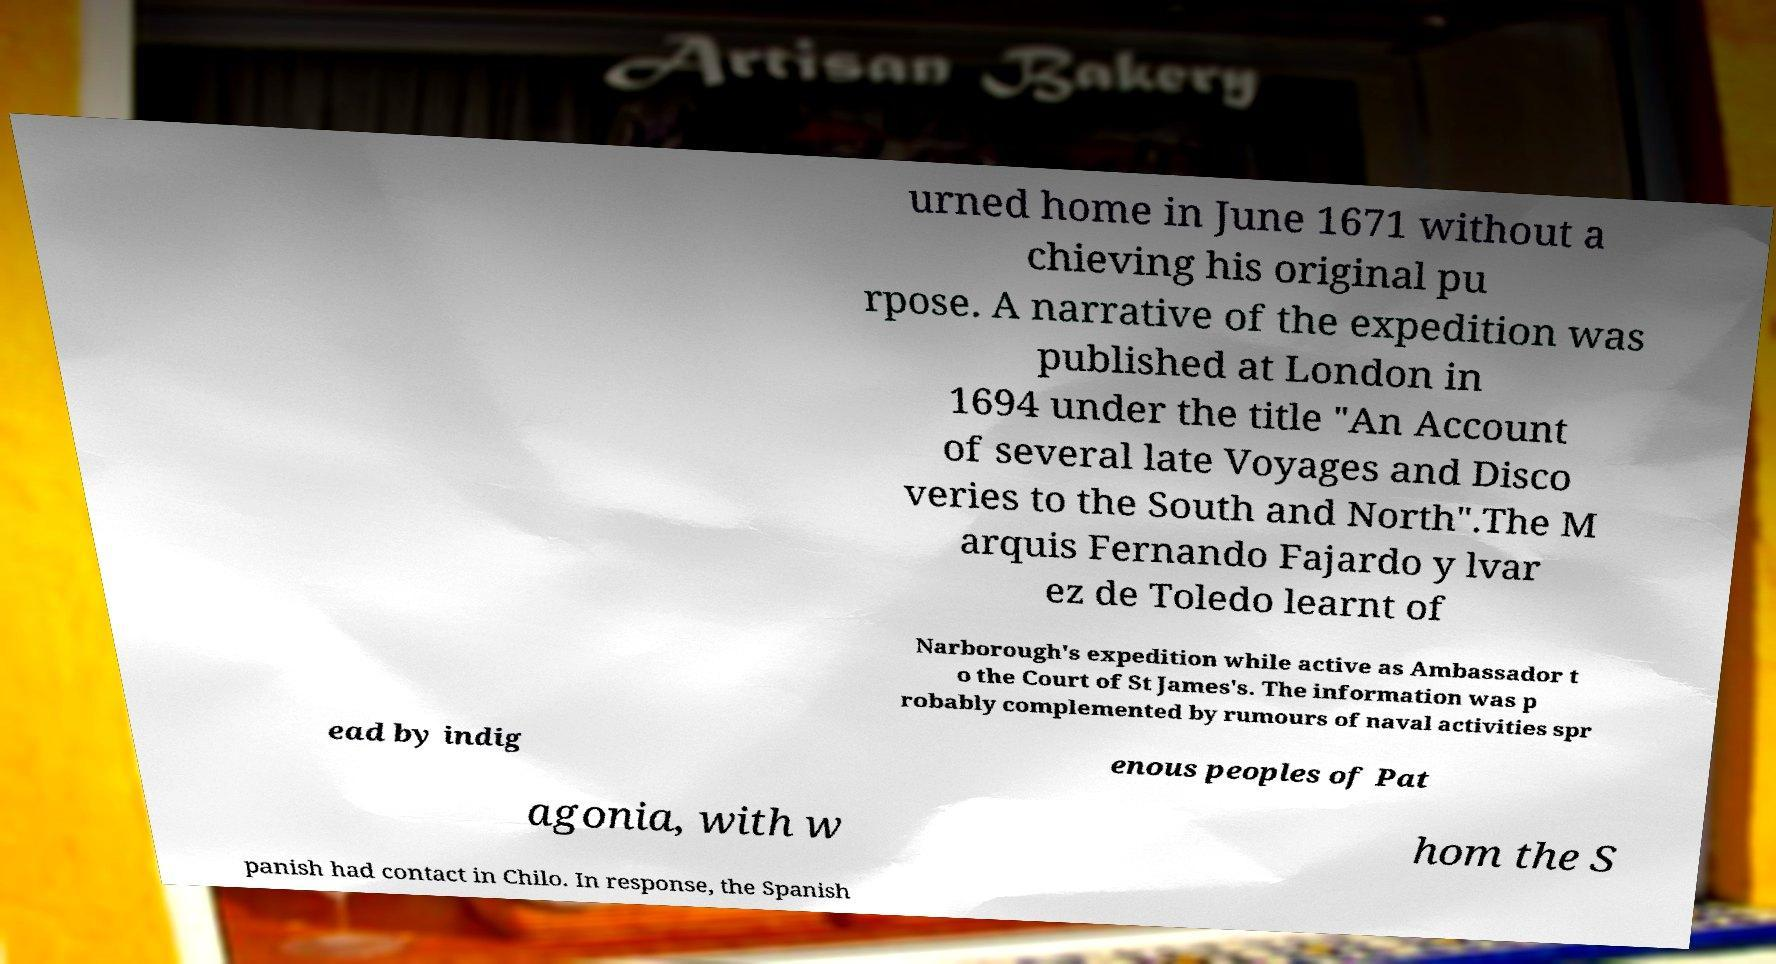I need the written content from this picture converted into text. Can you do that? urned home in June 1671 without a chieving his original pu rpose. A narrative of the expedition was published at London in 1694 under the title "An Account of several late Voyages and Disco veries to the South and North".The M arquis Fernando Fajardo y lvar ez de Toledo learnt of Narborough's expedition while active as Ambassador t o the Court of St James's. The information was p robably complemented by rumours of naval activities spr ead by indig enous peoples of Pat agonia, with w hom the S panish had contact in Chilo. In response, the Spanish 